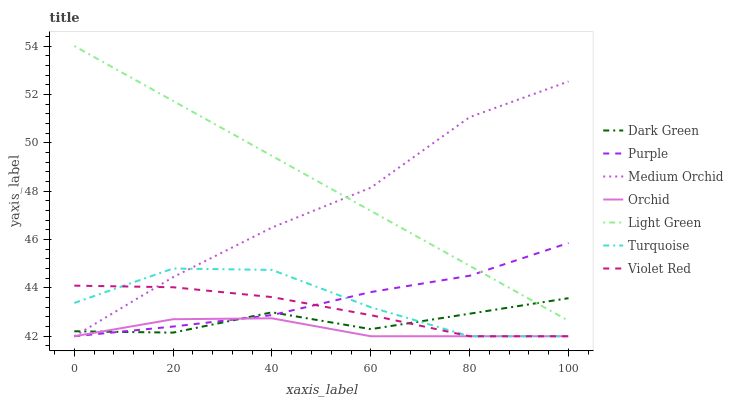Does Orchid have the minimum area under the curve?
Answer yes or no. Yes. Does Light Green have the maximum area under the curve?
Answer yes or no. Yes. Does Purple have the minimum area under the curve?
Answer yes or no. No. Does Purple have the maximum area under the curve?
Answer yes or no. No. Is Light Green the smoothest?
Answer yes or no. Yes. Is Turquoise the roughest?
Answer yes or no. Yes. Is Purple the smoothest?
Answer yes or no. No. Is Purple the roughest?
Answer yes or no. No. Does Turquoise have the lowest value?
Answer yes or no. Yes. Does Light Green have the lowest value?
Answer yes or no. No. Does Light Green have the highest value?
Answer yes or no. Yes. Does Purple have the highest value?
Answer yes or no. No. Is Orchid less than Light Green?
Answer yes or no. Yes. Is Light Green greater than Violet Red?
Answer yes or no. Yes. Does Orchid intersect Purple?
Answer yes or no. Yes. Is Orchid less than Purple?
Answer yes or no. No. Is Orchid greater than Purple?
Answer yes or no. No. Does Orchid intersect Light Green?
Answer yes or no. No. 